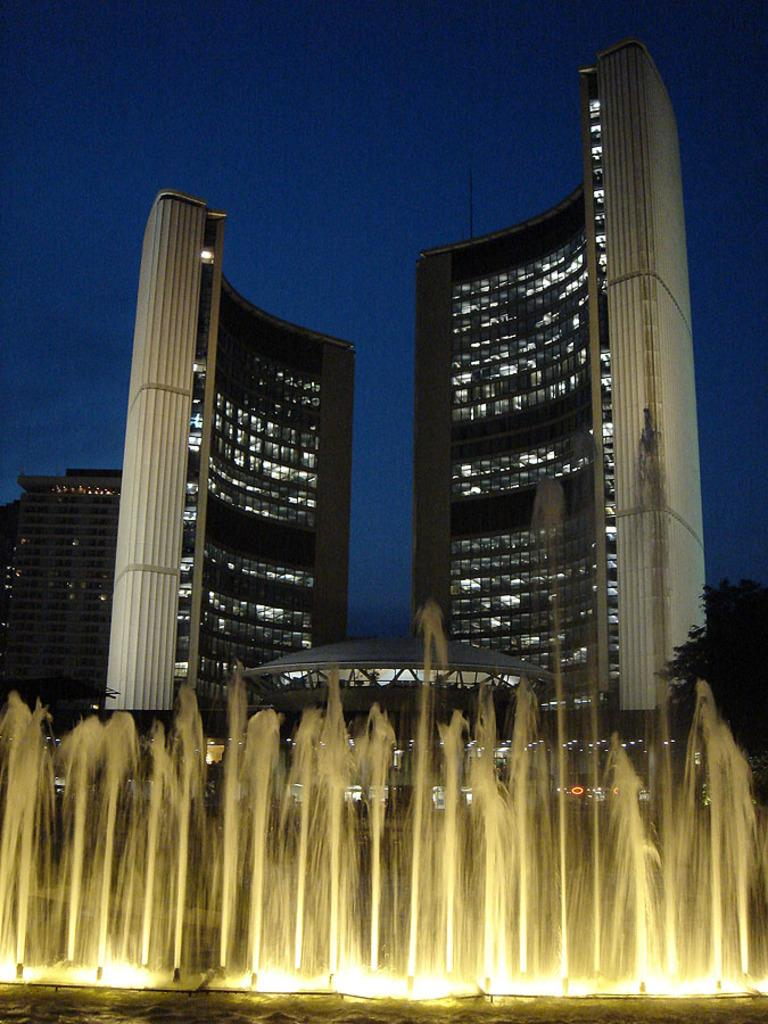What can be seen in the background of the image? The sky is visible in the background of the image. What type of structures are present in the image? There are buildings in the image. What is located at the bottom portion of the image? There is a water fountain and lights at the bottom portion of the image. Can you see any veins in the water fountain in the image? There are no veins present in the water fountain in the image. What type of thrill can be experienced by the lights in the image? The lights in the image are not capable of experiencing any thrill, as they are inanimate objects. 